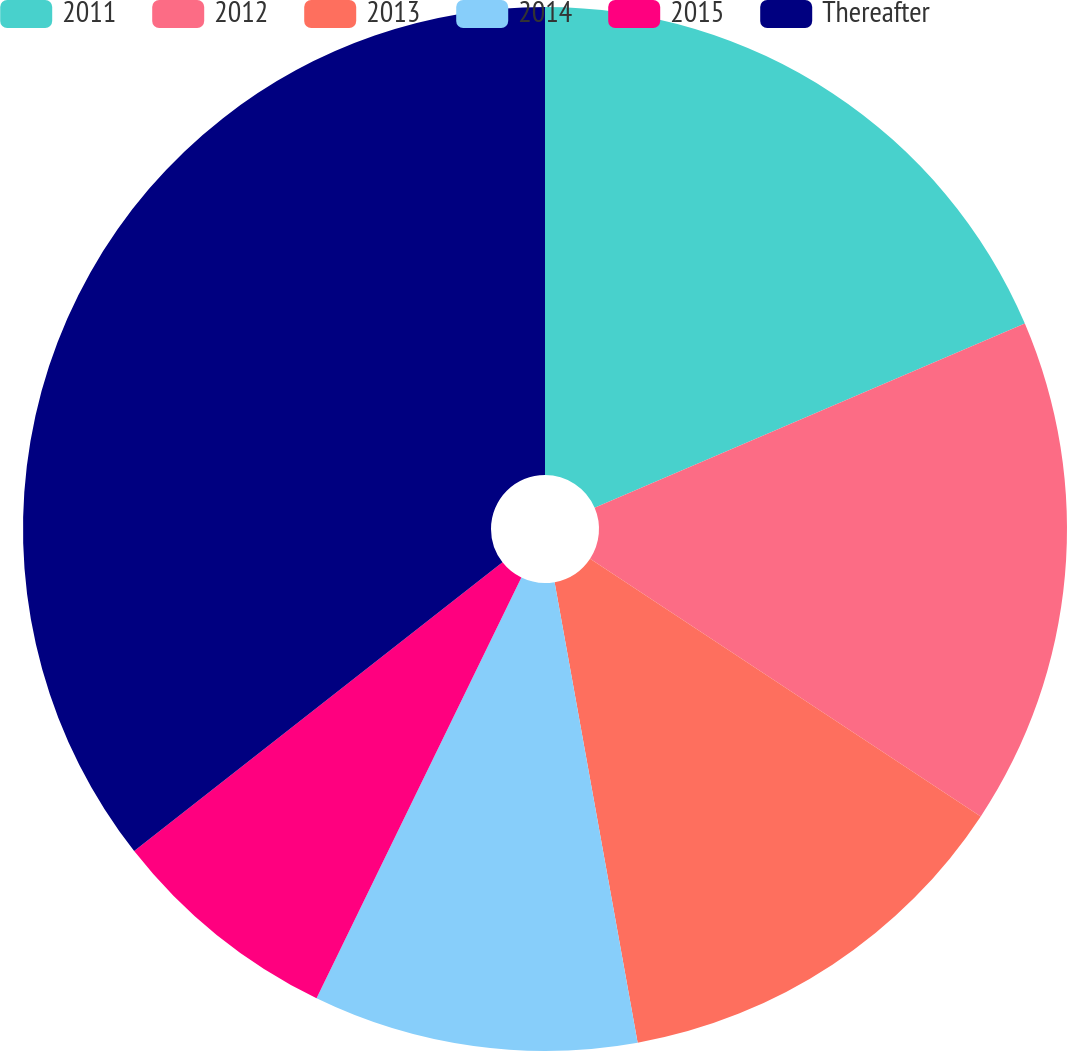Convert chart. <chart><loc_0><loc_0><loc_500><loc_500><pie_chart><fcel>2011<fcel>2012<fcel>2013<fcel>2014<fcel>2015<fcel>Thereafter<nl><fcel>18.56%<fcel>15.72%<fcel>12.88%<fcel>10.05%<fcel>7.21%<fcel>35.58%<nl></chart> 